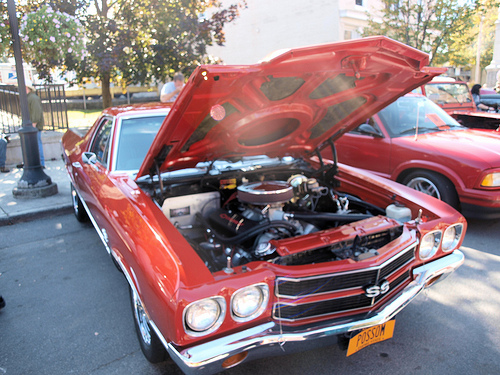<image>
Is the car behind the tree? No. The car is not behind the tree. From this viewpoint, the car appears to be positioned elsewhere in the scene. 